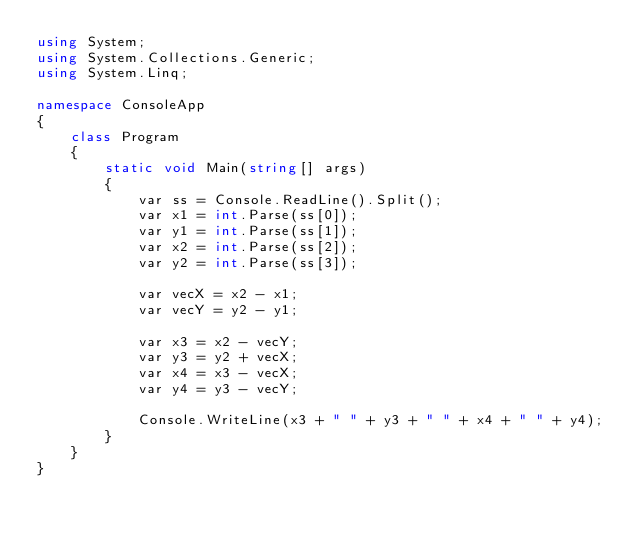<code> <loc_0><loc_0><loc_500><loc_500><_C#_>using System;
using System.Collections.Generic;
using System.Linq;

namespace ConsoleApp
{
    class Program
    {
        static void Main(string[] args)
        {
            var ss = Console.ReadLine().Split();
            var x1 = int.Parse(ss[0]);
            var y1 = int.Parse(ss[1]);
            var x2 = int.Parse(ss[2]);
            var y2 = int.Parse(ss[3]);

            var vecX = x2 - x1;
            var vecY = y2 - y1;

            var x3 = x2 - vecY;
            var y3 = y2 + vecX;
            var x4 = x3 - vecX;
            var y4 = y3 - vecY;

            Console.WriteLine(x3 + " " + y3 + " " + x4 + " " + y4);
        }
    }
}</code> 